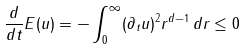Convert formula to latex. <formula><loc_0><loc_0><loc_500><loc_500>\frac { d } { d t } E ( u ) = - \int _ { 0 } ^ { \infty } ( \partial _ { t } u ) ^ { 2 } r ^ { d - 1 } \, d r \leq 0</formula> 